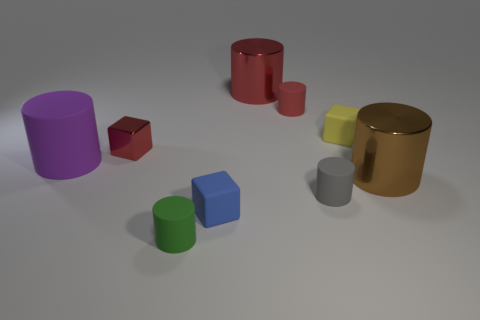Are there fewer large objects than big metallic balls?
Your answer should be very brief. No. What number of other things are made of the same material as the small yellow cube?
Your response must be concise. 5. What size is the red metallic object that is the same shape as the small yellow thing?
Offer a terse response. Small. Is the material of the cube that is in front of the big brown thing the same as the big red object that is behind the tiny red metal object?
Give a very brief answer. No. Is the number of blue things left of the blue rubber object less than the number of tiny gray spheres?
Your answer should be very brief. No. Are there any other things that are the same shape as the purple rubber thing?
Offer a terse response. Yes. The other tiny matte object that is the same shape as the yellow rubber object is what color?
Your answer should be very brief. Blue. There is a cube left of the green rubber cylinder; does it have the same size as the tiny yellow block?
Provide a short and direct response. Yes. What size is the metallic cylinder left of the metal cylinder that is in front of the big red metallic object?
Keep it short and to the point. Large. Do the tiny gray object and the small object to the left of the green cylinder have the same material?
Your response must be concise. No. 